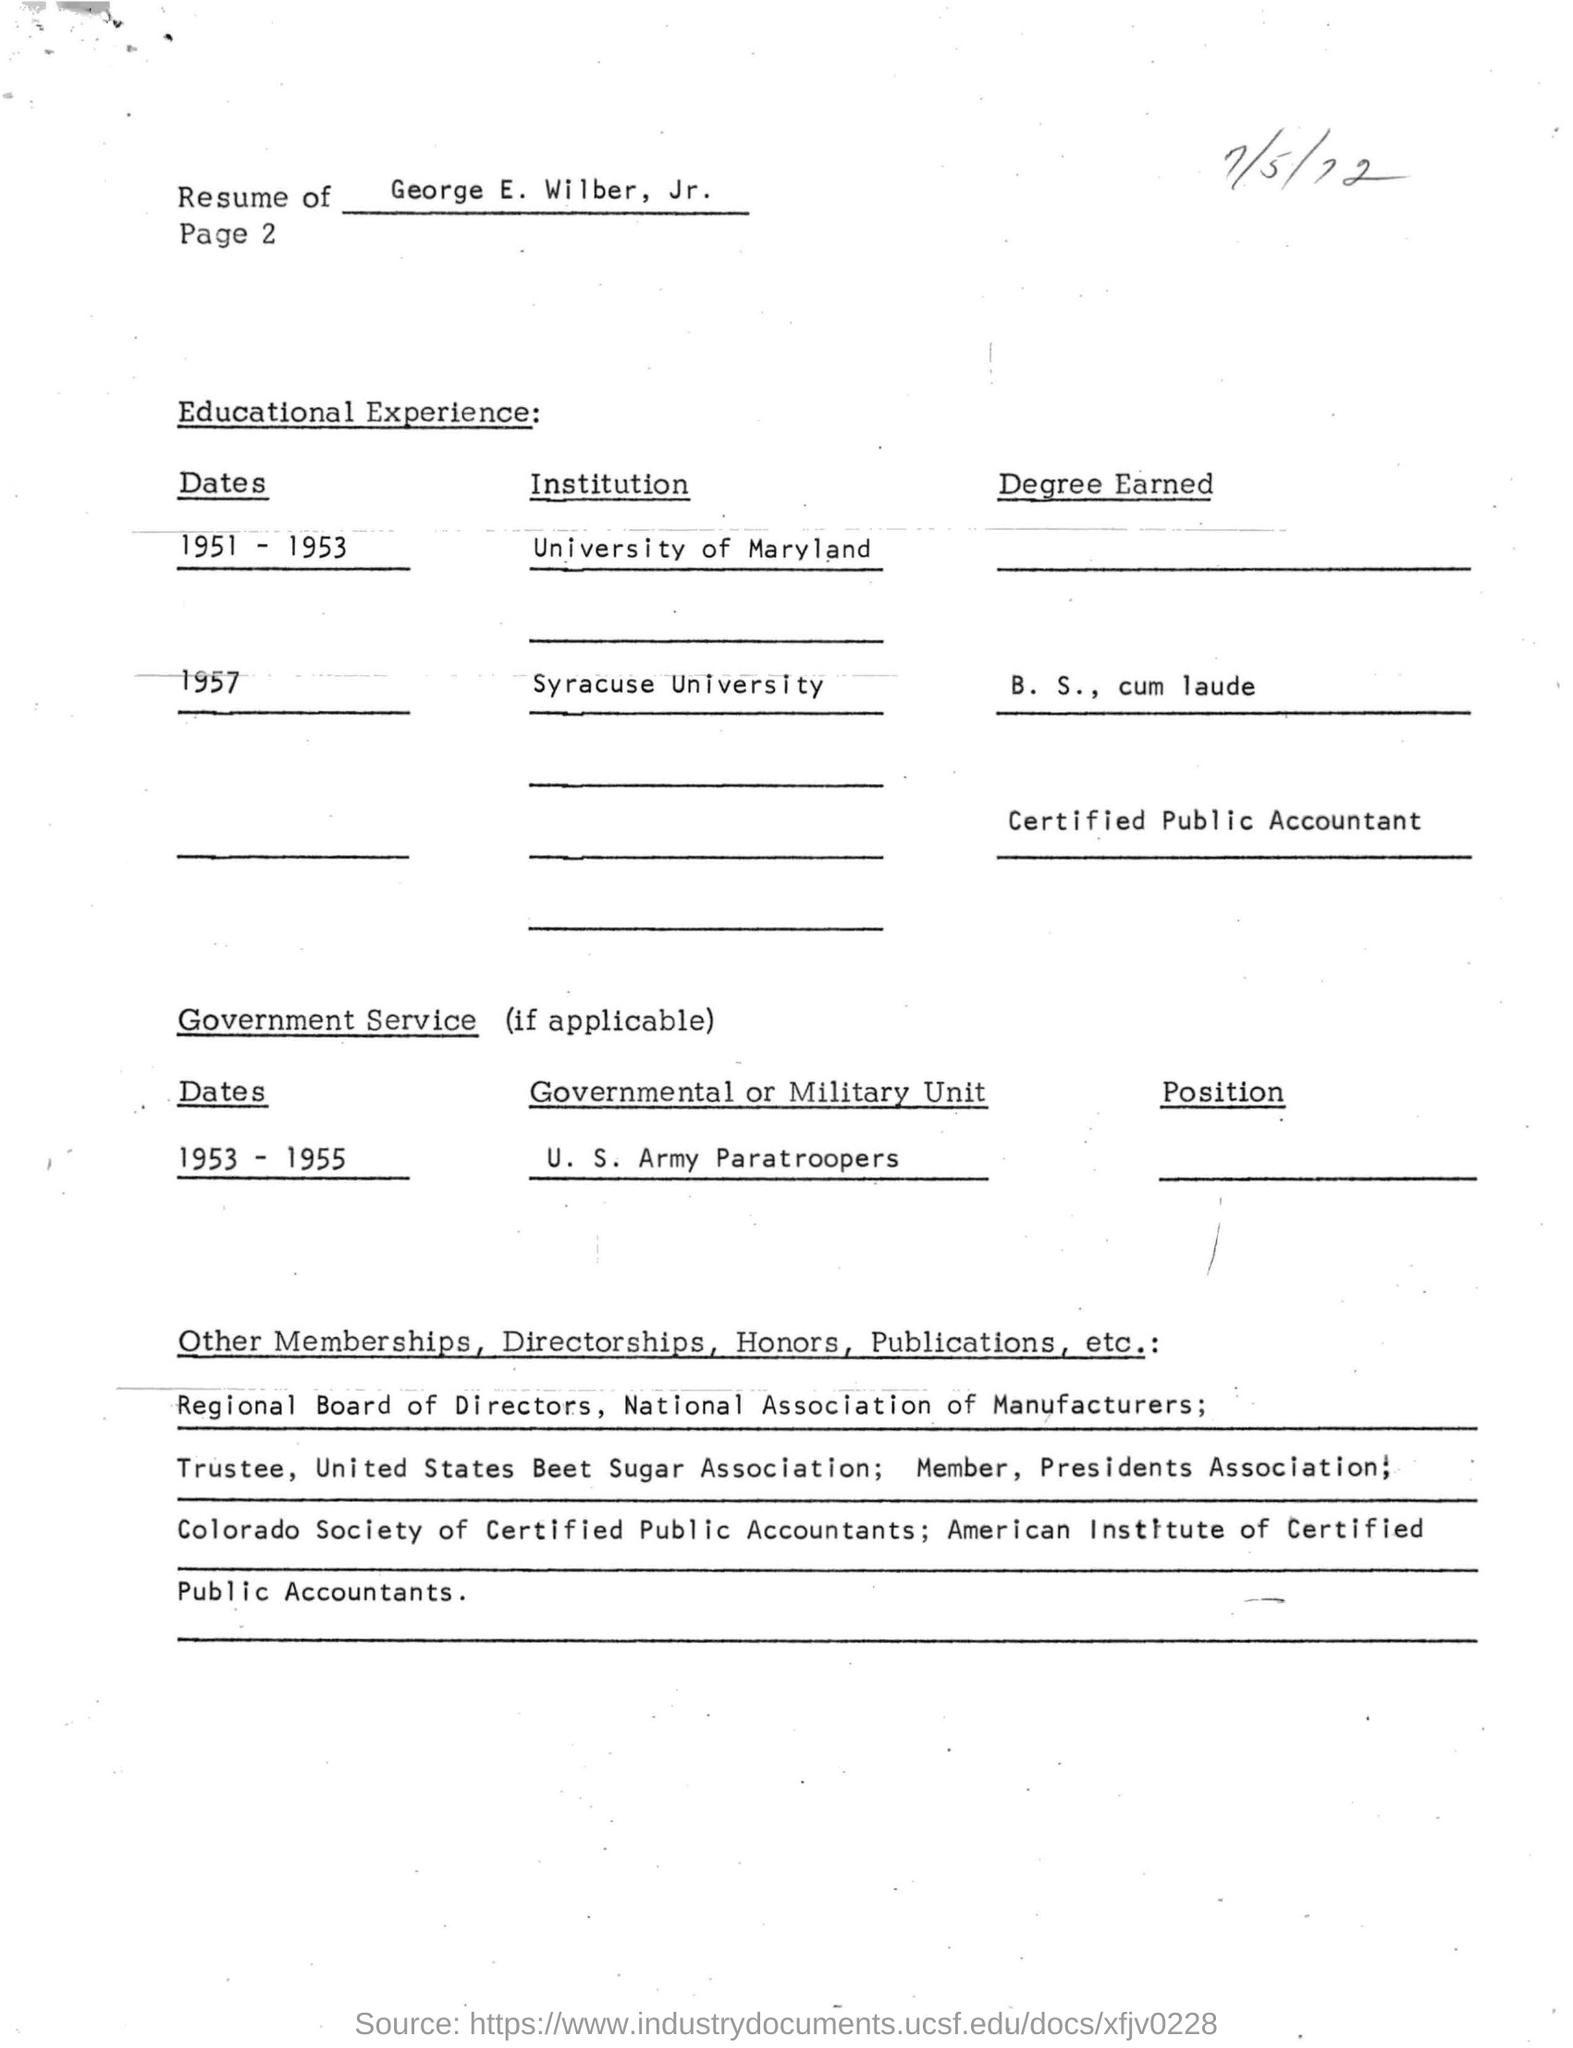Whose resume is given here?
Your answer should be very brief. George E Wilber,  Jr. When did George E Wilber,  Jr. completed his B.S degree?
Provide a succinct answer. 1957. During which year, George E Wilber,  Jr. served in the U. S. Army Paratroopers?
Offer a terse response. 1953 - 1955. 